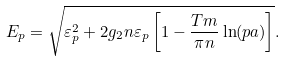Convert formula to latex. <formula><loc_0><loc_0><loc_500><loc_500>E _ { p } = \sqrt { \varepsilon _ { p } ^ { 2 } + 2 { g _ { 2 } } n \varepsilon _ { p } \left [ 1 - \frac { T m } { \pi n } \ln ( p a ) \right ] } .</formula> 